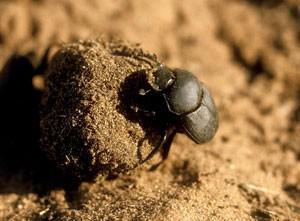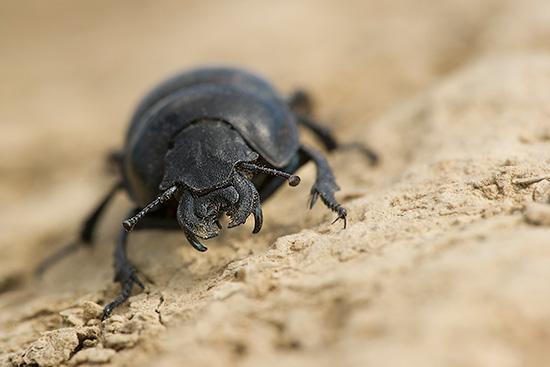The first image is the image on the left, the second image is the image on the right. Assess this claim about the two images: "There is a beetle that that's at the very top of a dungball.". Correct or not? Answer yes or no. No. The first image is the image on the left, the second image is the image on the right. For the images displayed, is the sentence "There is a beetle that is not in contact with a ball in one image." factually correct? Answer yes or no. Yes. 